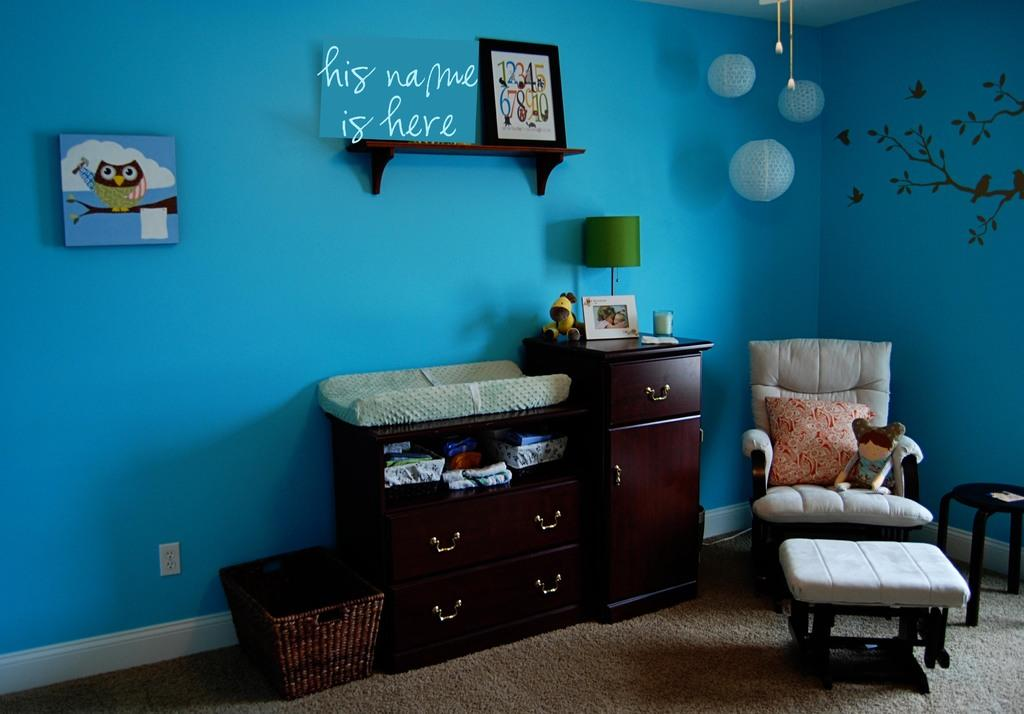<image>
Summarize the visual content of the image. A living room with a blue wall a blue sign on a shelf saying, his name here. 